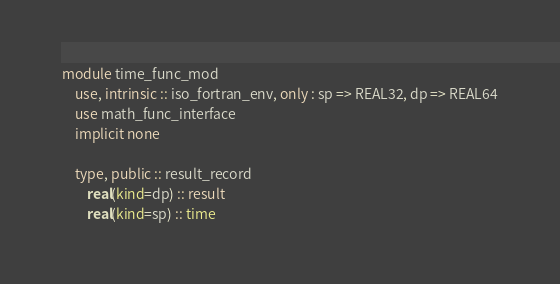<code> <loc_0><loc_0><loc_500><loc_500><_FORTRAN_>module time_func_mod
    use, intrinsic :: iso_fortran_env, only : sp => REAL32, dp => REAL64
    use math_func_interface
    implicit none

    type, public :: result_record
        real(kind=dp) :: result
        real(kind=sp) :: time</code> 